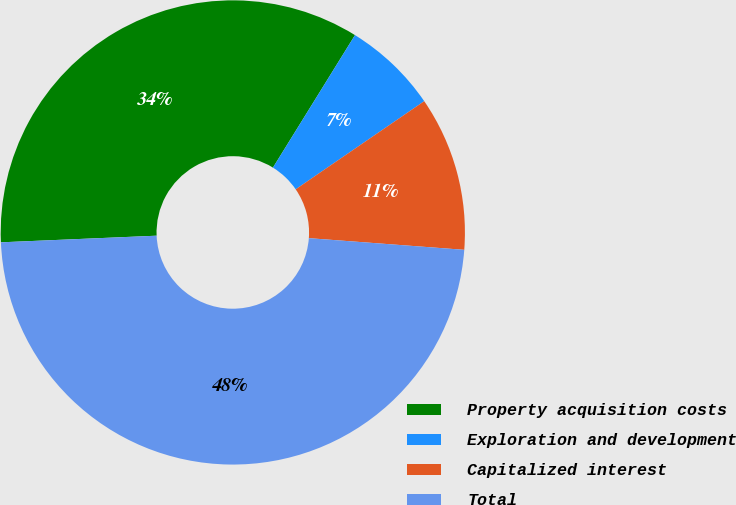Convert chart to OTSL. <chart><loc_0><loc_0><loc_500><loc_500><pie_chart><fcel>Property acquisition costs<fcel>Exploration and development<fcel>Capitalized interest<fcel>Total<nl><fcel>34.5%<fcel>6.61%<fcel>10.76%<fcel>48.13%<nl></chart> 